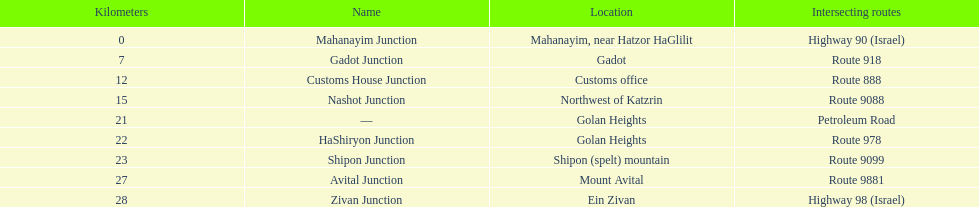What is the number of routes that intersect highway 91? 9. 